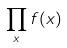<formula> <loc_0><loc_0><loc_500><loc_500>\prod _ { x } f ( x )</formula> 